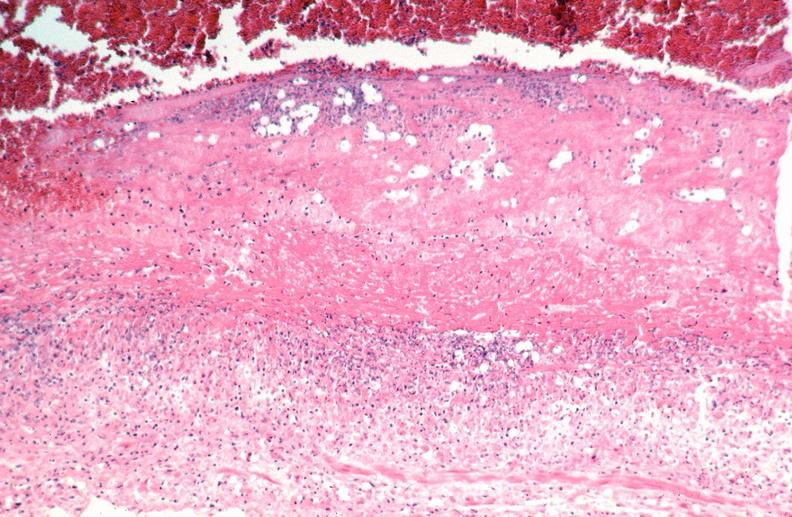where is this from?
Answer the question using a single word or phrase. Vasculature 